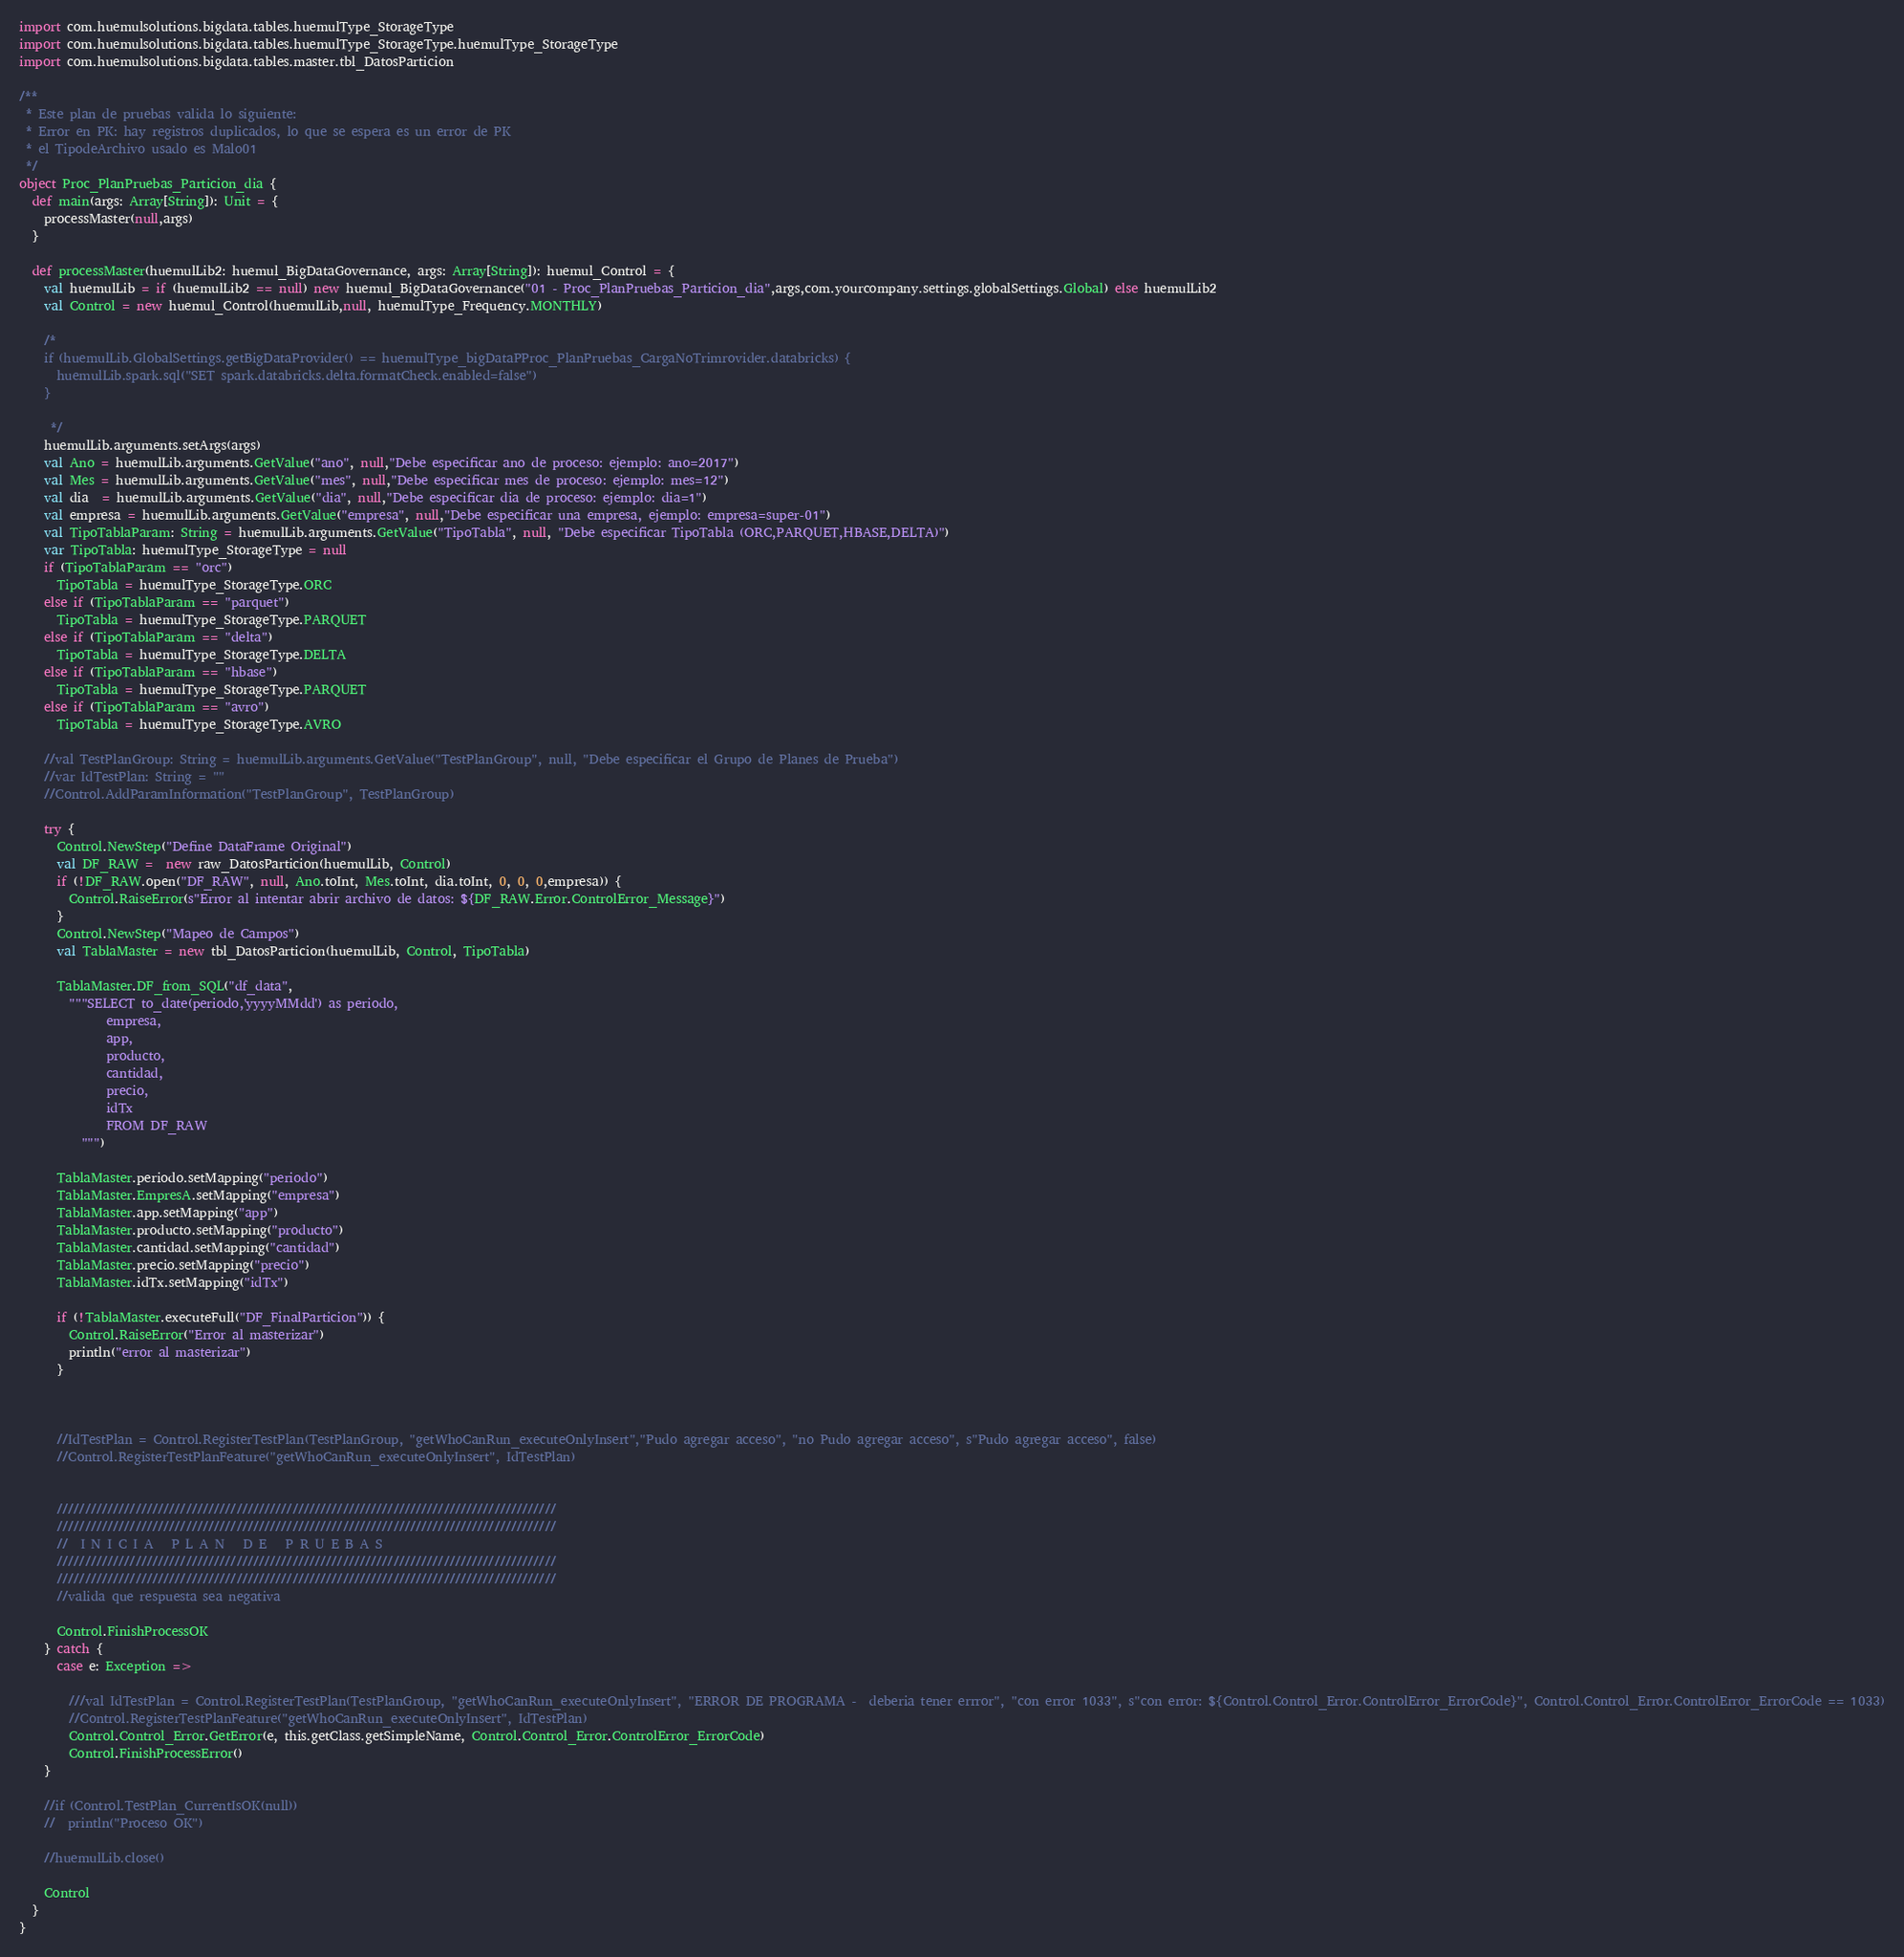Convert code to text. <code><loc_0><loc_0><loc_500><loc_500><_Scala_>import com.huemulsolutions.bigdata.tables.huemulType_StorageType
import com.huemulsolutions.bigdata.tables.huemulType_StorageType.huemulType_StorageType
import com.huemulsolutions.bigdata.tables.master.tbl_DatosParticion

/**
 * Este plan de pruebas valida lo siguiente:
 * Error en PK: hay registros duplicados, lo que se espera es un error de PK
 * el TipodeArchivo usado es Malo01
 */
object Proc_PlanPruebas_Particion_dia {
  def main(args: Array[String]): Unit = {
    processMaster(null,args)
  }

  def processMaster(huemulLib2: huemul_BigDataGovernance, args: Array[String]): huemul_Control = {
    val huemulLib = if (huemulLib2 == null) new huemul_BigDataGovernance("01 - Proc_PlanPruebas_Particion_dia",args,com.yourcompany.settings.globalSettings.Global) else huemulLib2
    val Control = new huemul_Control(huemulLib,null, huemulType_Frequency.MONTHLY)

    /*
    if (huemulLib.GlobalSettings.getBigDataProvider() == huemulType_bigDataPProc_PlanPruebas_CargaNoTrimrovider.databricks) {
      huemulLib.spark.sql("SET spark.databricks.delta.formatCheck.enabled=false")
    }

     */
    huemulLib.arguments.setArgs(args)
    val Ano = huemulLib.arguments.GetValue("ano", null,"Debe especificar ano de proceso: ejemplo: ano=2017")
    val Mes = huemulLib.arguments.GetValue("mes", null,"Debe especificar mes de proceso: ejemplo: mes=12")
    val dia  = huemulLib.arguments.GetValue("dia", null,"Debe especificar dia de proceso: ejemplo: dia=1")
    val empresa = huemulLib.arguments.GetValue("empresa", null,"Debe especificar una empresa, ejemplo: empresa=super-01")
    val TipoTablaParam: String = huemulLib.arguments.GetValue("TipoTabla", null, "Debe especificar TipoTabla (ORC,PARQUET,HBASE,DELTA)")
    var TipoTabla: huemulType_StorageType = null
    if (TipoTablaParam == "orc")
      TipoTabla = huemulType_StorageType.ORC
    else if (TipoTablaParam == "parquet")
      TipoTabla = huemulType_StorageType.PARQUET
    else if (TipoTablaParam == "delta")
      TipoTabla = huemulType_StorageType.DELTA
    else if (TipoTablaParam == "hbase")
      TipoTabla = huemulType_StorageType.PARQUET
    else if (TipoTablaParam == "avro")
      TipoTabla = huemulType_StorageType.AVRO

    //val TestPlanGroup: String = huemulLib.arguments.GetValue("TestPlanGroup", null, "Debe especificar el Grupo de Planes de Prueba")
    //var IdTestPlan: String = ""
    //Control.AddParamInformation("TestPlanGroup", TestPlanGroup)
        
    try {
      Control.NewStep("Define DataFrame Original")
      val DF_RAW =  new raw_DatosParticion(huemulLib, Control)
      if (!DF_RAW.open("DF_RAW", null, Ano.toInt, Mes.toInt, dia.toInt, 0, 0, 0,empresa)) {
        Control.RaiseError(s"Error al intentar abrir archivo de datos: ${DF_RAW.Error.ControlError_Message}")
      }
      Control.NewStep("Mapeo de Campos")
      val TablaMaster = new tbl_DatosParticion(huemulLib, Control, TipoTabla)

      TablaMaster.DF_from_SQL("df_data",
        """SELECT to_date(periodo,'yyyyMMdd') as periodo,
              empresa,
              app,
              producto,
              cantidad,
              precio,
              idTx
              FROM DF_RAW
          """)

      TablaMaster.periodo.setMapping("periodo")
      TablaMaster.EmpresA.setMapping("empresa")
      TablaMaster.app.setMapping("app")
      TablaMaster.producto.setMapping("producto")
      TablaMaster.cantidad.setMapping("cantidad")
      TablaMaster.precio.setMapping("precio")
      TablaMaster.idTx.setMapping("idTx")

      if (!TablaMaster.executeFull("DF_FinalParticion")) {
        Control.RaiseError("Error al masterizar")
        println("error al masterizar")
      }

  
      
      //IdTestPlan = Control.RegisterTestPlan(TestPlanGroup, "getWhoCanRun_executeOnlyInsert","Pudo agregar acceso", "no Pudo agregar acceso", s"Pudo agregar acceso", false)
      //Control.RegisterTestPlanFeature("getWhoCanRun_executeOnlyInsert", IdTestPlan)
      
      
      /////////////////////////////////////////////////////////////////////////////////////////
      /////////////////////////////////////////////////////////////////////////////////////////
      //  I N I C I A   P L A N   D E   P R U E B A S
      /////////////////////////////////////////////////////////////////////////////////////////
      /////////////////////////////////////////////////////////////////////////////////////////
      //valida que respuesta sea negativa
      
      Control.FinishProcessOK
    } catch {
      case e: Exception => 
        
        ///val IdTestPlan = Control.RegisterTestPlan(TestPlanGroup, "getWhoCanRun_executeOnlyInsert", "ERROR DE PROGRAMA -  deberia tener errror", "con error 1033", s"con error: ${Control.Control_Error.ControlError_ErrorCode}", Control.Control_Error.ControlError_ErrorCode == 1033)
        //Control.RegisterTestPlanFeature("getWhoCanRun_executeOnlyInsert", IdTestPlan)
        Control.Control_Error.GetError(e, this.getClass.getSimpleName, Control.Control_Error.ControlError_ErrorCode)
        Control.FinishProcessError()
    }
    
    //if (Control.TestPlan_CurrentIsOK(null))
    //  println("Proceso OK")
    
    //huemulLib.close()

    Control
  }
}</code> 